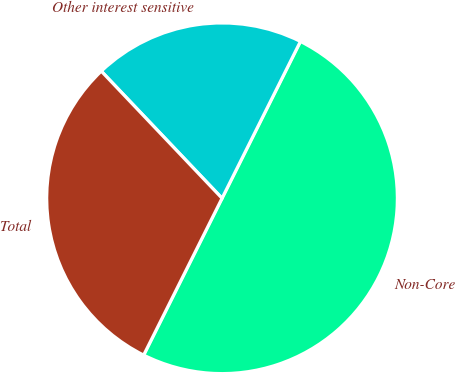Convert chart. <chart><loc_0><loc_0><loc_500><loc_500><pie_chart><fcel>Non-Core<fcel>Other interest sensitive<fcel>Total<nl><fcel>50.0%<fcel>19.47%<fcel>30.53%<nl></chart> 